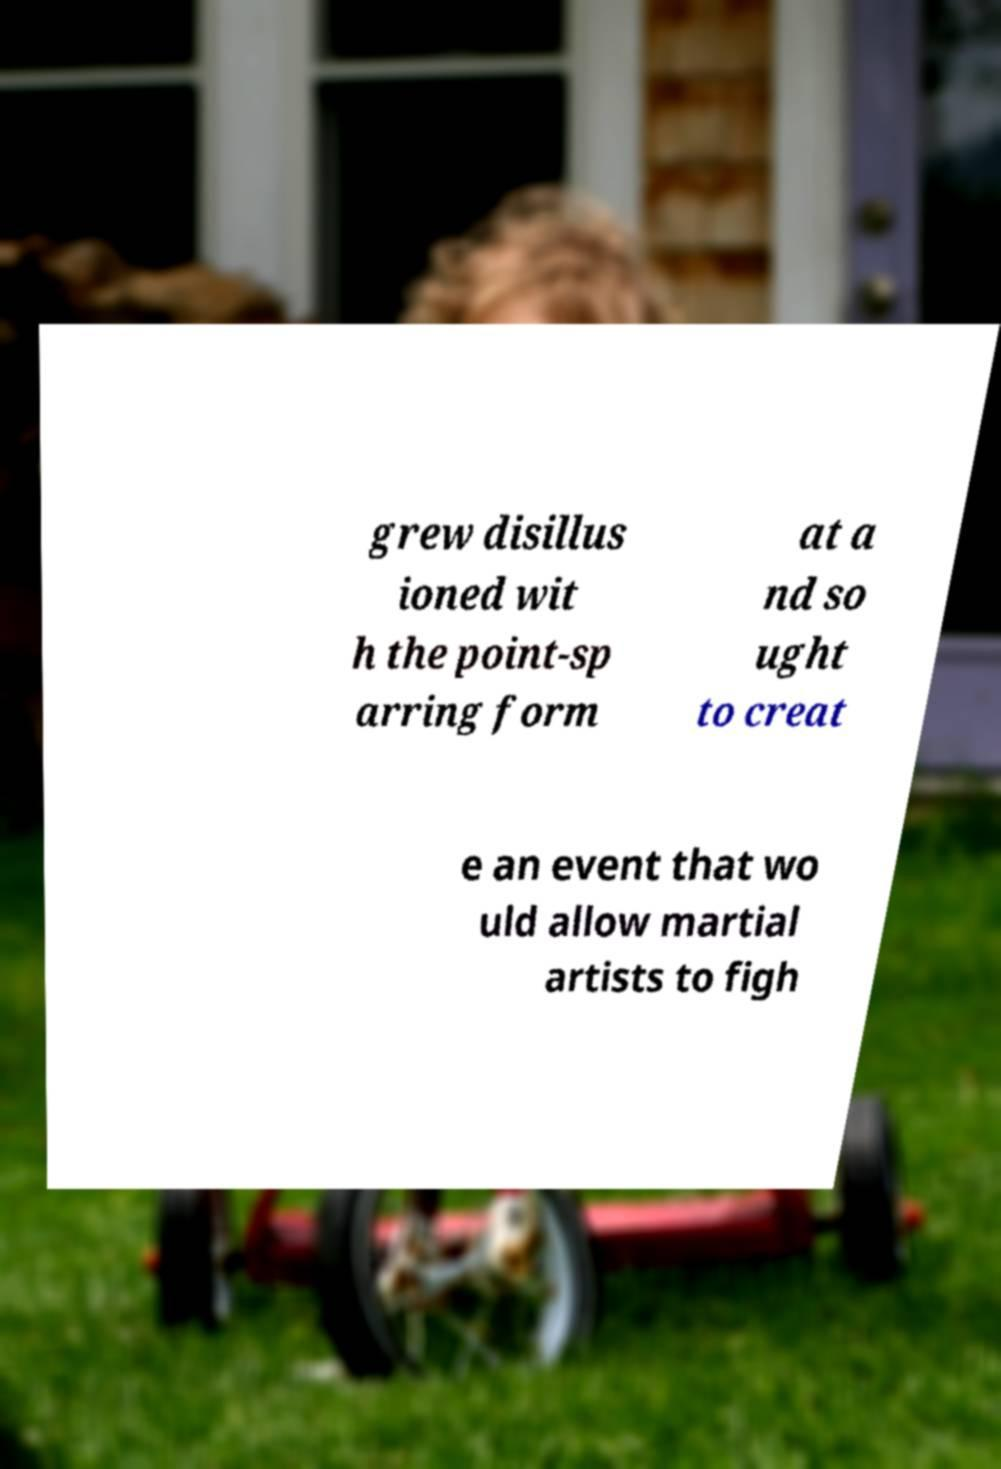Could you extract and type out the text from this image? grew disillus ioned wit h the point-sp arring form at a nd so ught to creat e an event that wo uld allow martial artists to figh 